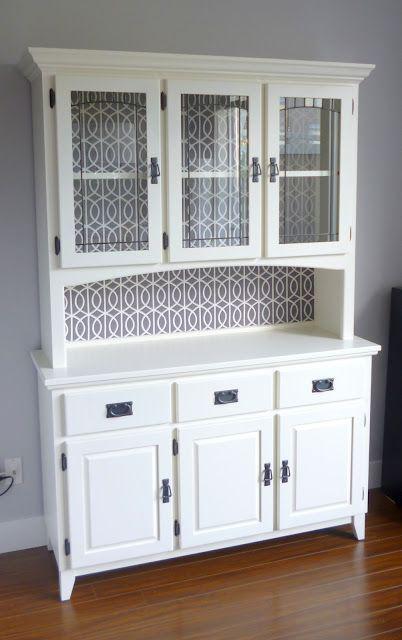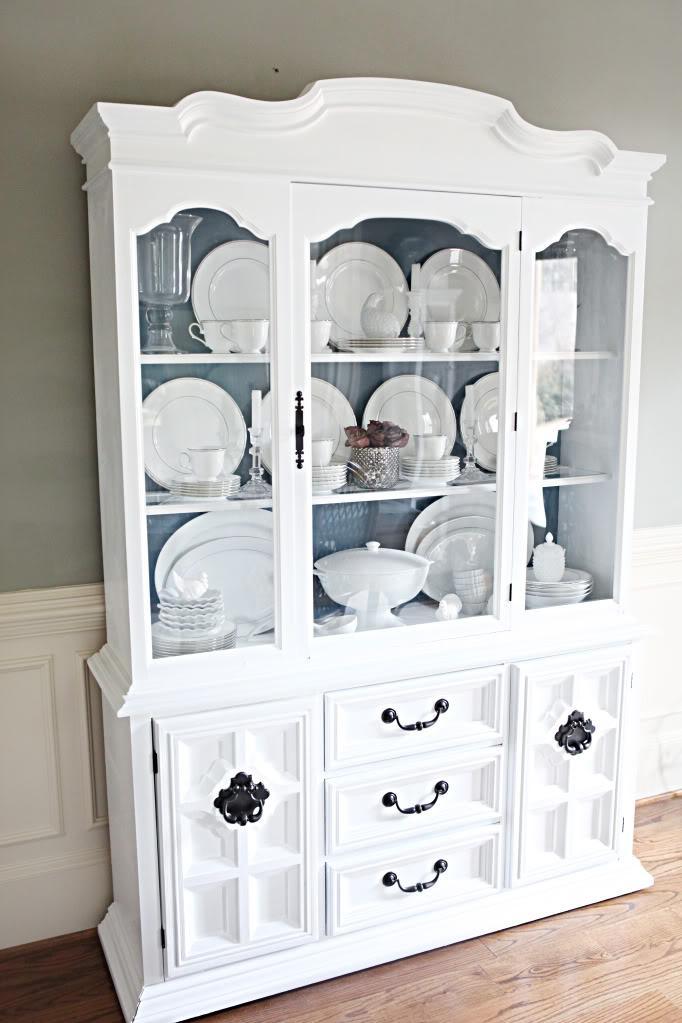The first image is the image on the left, the second image is the image on the right. For the images displayed, is the sentence "At least one of the cabinets has an arched top as well as some type of legs." factually correct? Answer yes or no. No. The first image is the image on the left, the second image is the image on the right. Considering the images on both sides, is "A wooden hutch with three rows of dishes in its upper section has at least two drawers with pulls between doors in the bottom section." valid? Answer yes or no. Yes. 